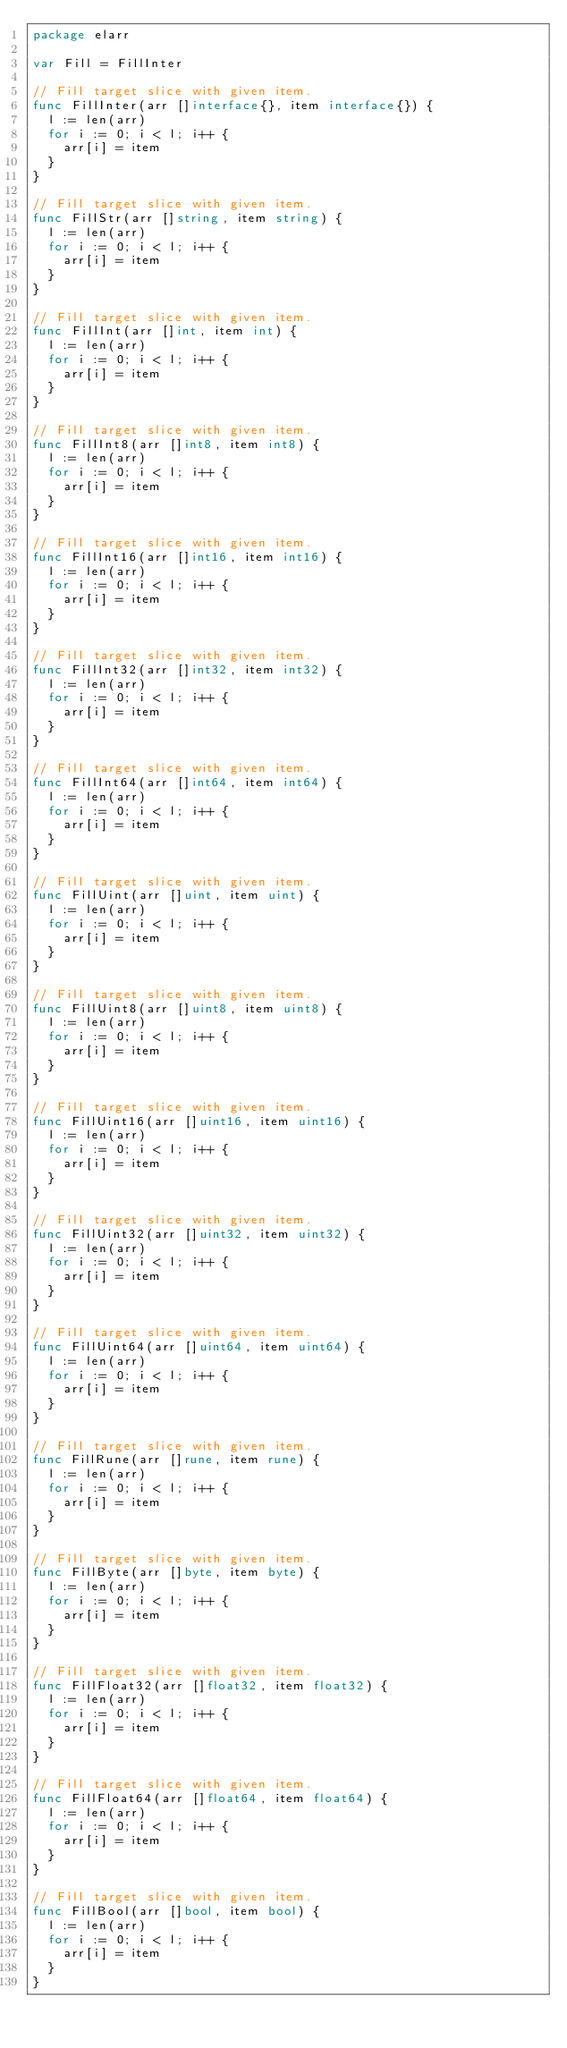Convert code to text. <code><loc_0><loc_0><loc_500><loc_500><_Go_>package elarr

var Fill = FillInter

// Fill target slice with given item.
func FillInter(arr []interface{}, item interface{}) {
	l := len(arr)
	for i := 0; i < l; i++ {
		arr[i] = item
	}
}

// Fill target slice with given item.
func FillStr(arr []string, item string) {
	l := len(arr)
	for i := 0; i < l; i++ {
		arr[i] = item
	}
}

// Fill target slice with given item.
func FillInt(arr []int, item int) {
	l := len(arr)
	for i := 0; i < l; i++ {
		arr[i] = item
	}
}

// Fill target slice with given item.
func FillInt8(arr []int8, item int8) {
	l := len(arr)
	for i := 0; i < l; i++ {
		arr[i] = item
	}
}

// Fill target slice with given item.
func FillInt16(arr []int16, item int16) {
	l := len(arr)
	for i := 0; i < l; i++ {
		arr[i] = item
	}
}

// Fill target slice with given item.
func FillInt32(arr []int32, item int32) {
	l := len(arr)
	for i := 0; i < l; i++ {
		arr[i] = item
	}
}

// Fill target slice with given item.
func FillInt64(arr []int64, item int64) {
	l := len(arr)
	for i := 0; i < l; i++ {
		arr[i] = item
	}
}

// Fill target slice with given item.
func FillUint(arr []uint, item uint) {
	l := len(arr)
	for i := 0; i < l; i++ {
		arr[i] = item
	}
}

// Fill target slice with given item.
func FillUint8(arr []uint8, item uint8) {
	l := len(arr)
	for i := 0; i < l; i++ {
		arr[i] = item
	}
}

// Fill target slice with given item.
func FillUint16(arr []uint16, item uint16) {
	l := len(arr)
	for i := 0; i < l; i++ {
		arr[i] = item
	}
}

// Fill target slice with given item.
func FillUint32(arr []uint32, item uint32) {
	l := len(arr)
	for i := 0; i < l; i++ {
		arr[i] = item
	}
}

// Fill target slice with given item.
func FillUint64(arr []uint64, item uint64) {
	l := len(arr)
	for i := 0; i < l; i++ {
		arr[i] = item
	}
}

// Fill target slice with given item.
func FillRune(arr []rune, item rune) {
	l := len(arr)
	for i := 0; i < l; i++ {
		arr[i] = item
	}
}

// Fill target slice with given item.
func FillByte(arr []byte, item byte) {
	l := len(arr)
	for i := 0; i < l; i++ {
		arr[i] = item
	}
}

// Fill target slice with given item.
func FillFloat32(arr []float32, item float32) {
	l := len(arr)
	for i := 0; i < l; i++ {
		arr[i] = item
	}
}

// Fill target slice with given item.
func FillFloat64(arr []float64, item float64) {
	l := len(arr)
	for i := 0; i < l; i++ {
		arr[i] = item
	}
}

// Fill target slice with given item.
func FillBool(arr []bool, item bool) {
	l := len(arr)
	for i := 0; i < l; i++ {
		arr[i] = item
	}
}
</code> 